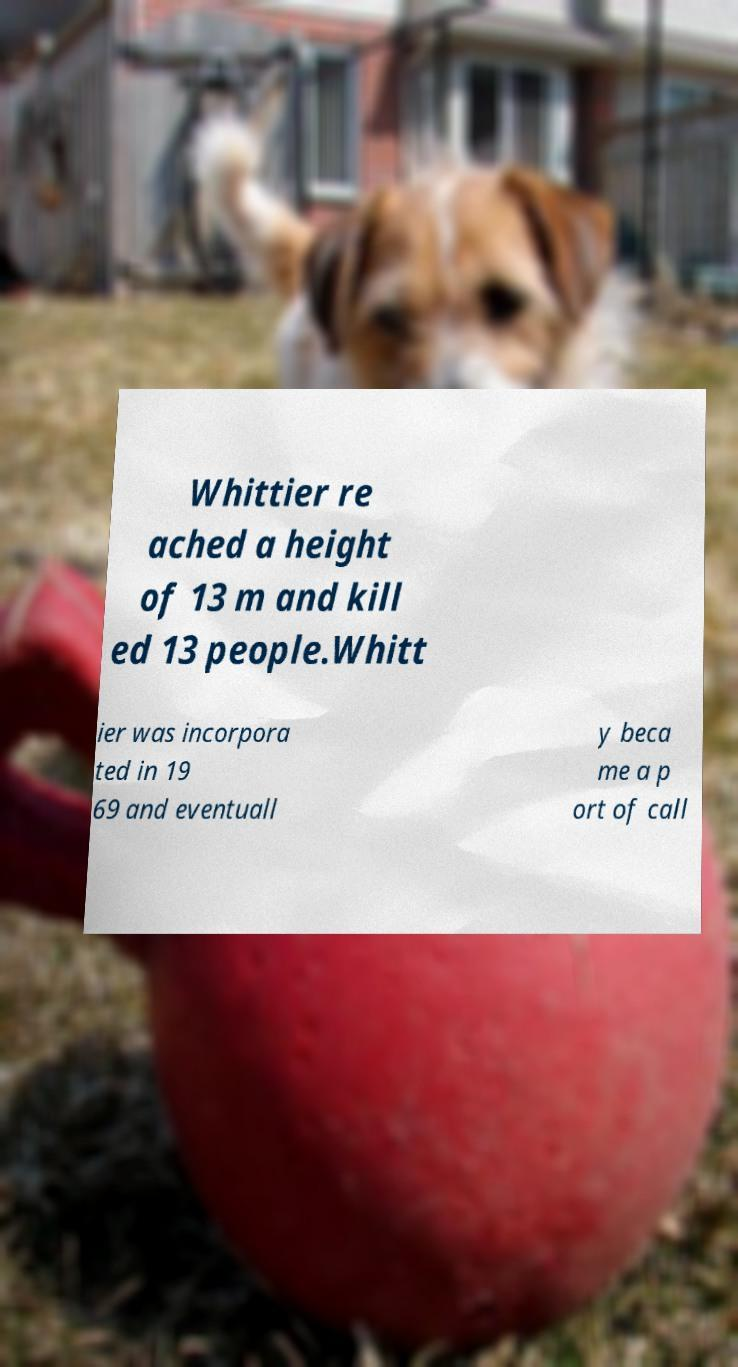For documentation purposes, I need the text within this image transcribed. Could you provide that? Whittier re ached a height of 13 m and kill ed 13 people.Whitt ier was incorpora ted in 19 69 and eventuall y beca me a p ort of call 